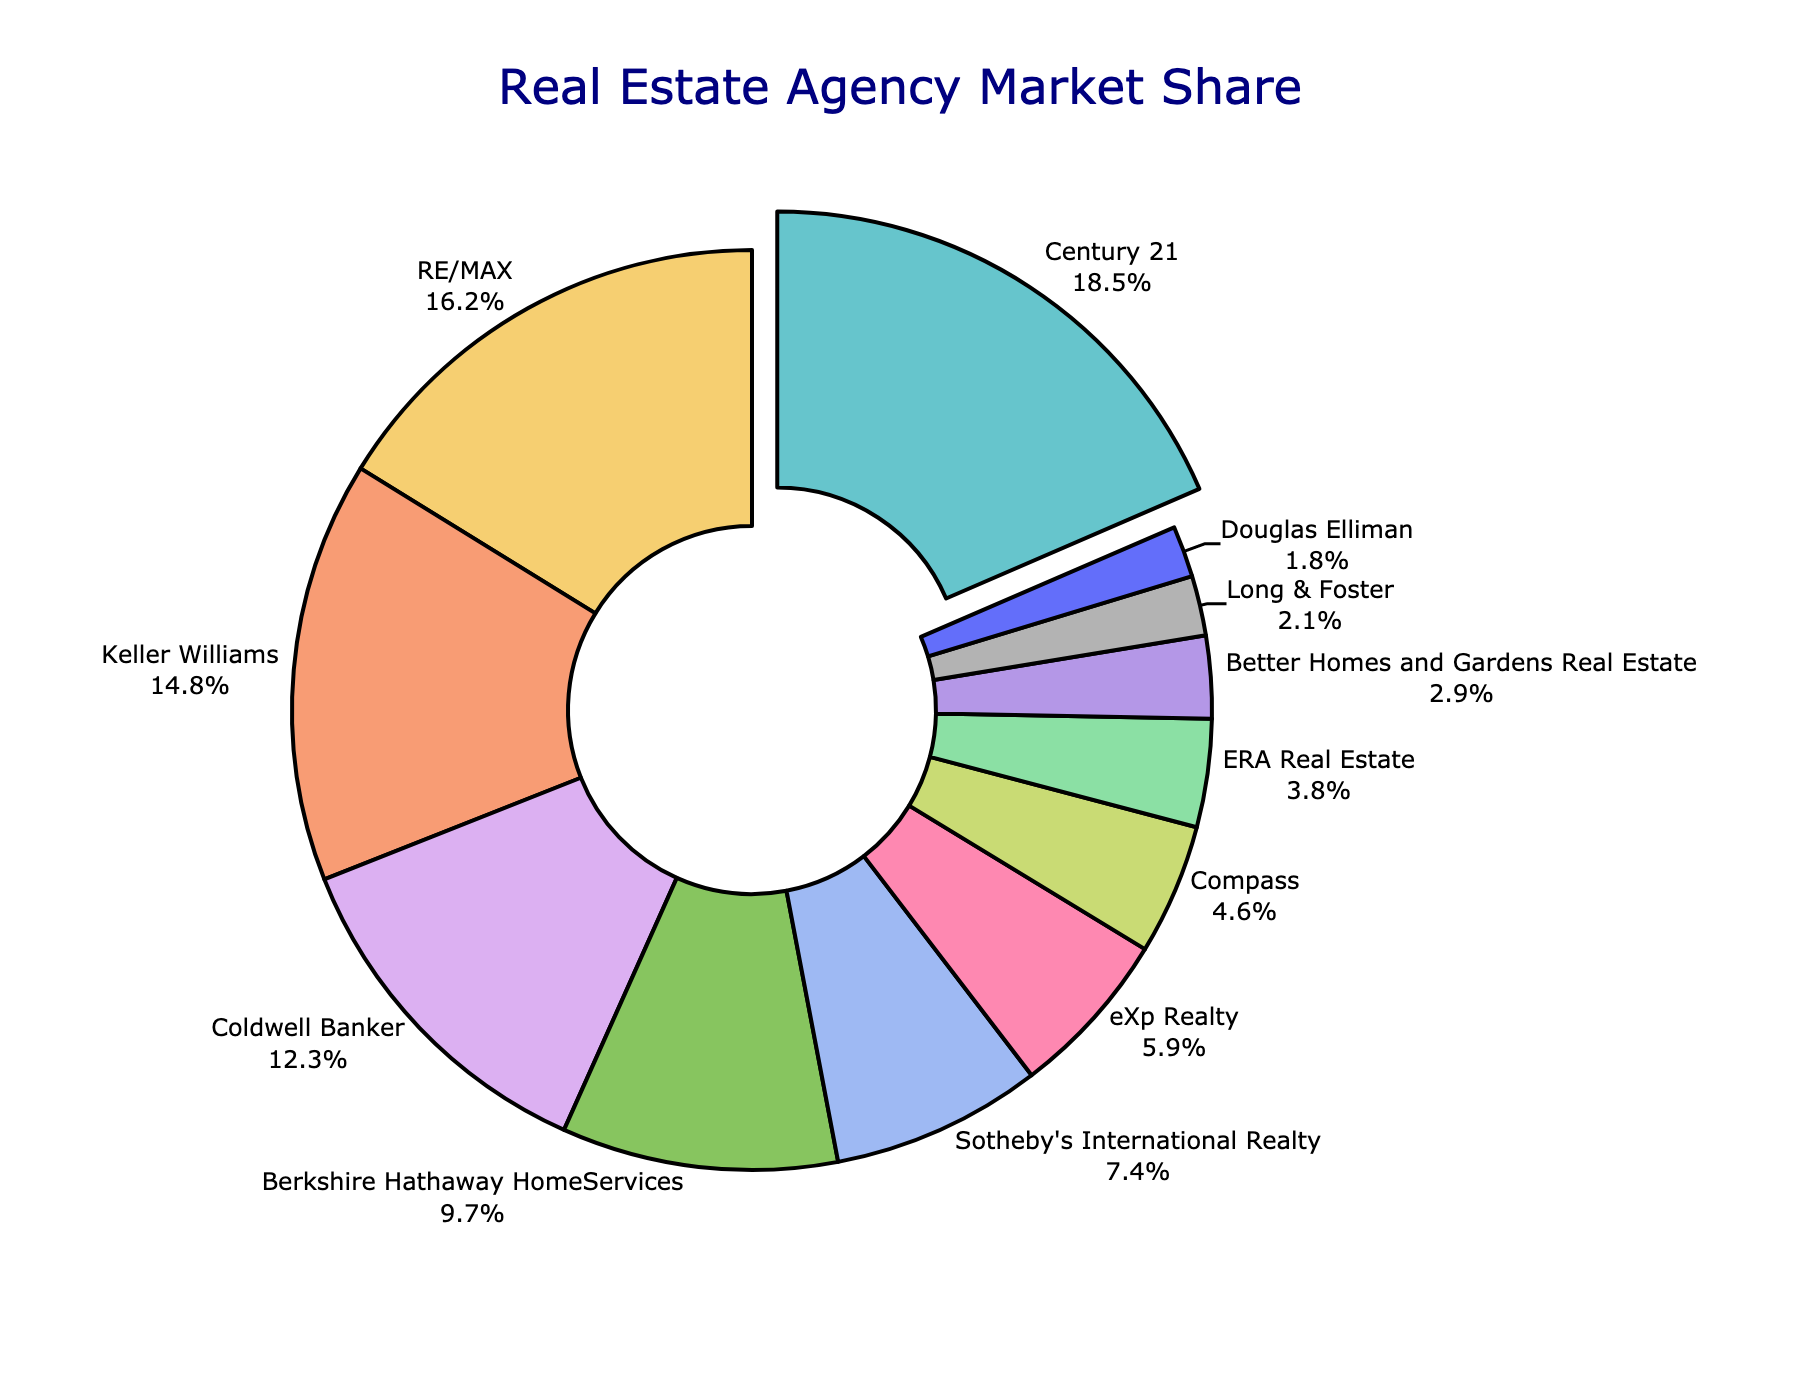What is the market share percentage of Century 21? Look at the pie chart and identify the section labeled "Century 21". The text will indicate its market share percentage.
Answer: 18.5% Which agency has the smallest market share? Observe the smallest section in the pie chart. The label which represents this section (Douglas Elliman) shows its market share.
Answer: Douglas Elliman What is the combined market share percentage of Century 21 and RE/MAX? Identify the sections labeled "Century 21" and "RE/MAX" on the pie chart. Sum their market share percentages: 18.5% + 16.2% = 34.7%.
Answer: 34.7% What is the difference in market share between Coldwell Banker and Berkshire Hathaway HomeServices? Locate the sections for Coldwell Banker and Berkshire Hathaway HomeServices on the pie chart. Subtract Berkshire Hathaway's share from Coldwell Banker's: 12.3% - 9.7% = 2.6%.
Answer: 2.6% Is eXp Realty's market share greater than Compass's? Compare the market share percentages of eXp Realty (5.9%) and Compass (4.6%) visible on their respective sections. eXp Realty's market share is greater.
Answer: Yes Which agency has a market share closest to 5%? Find the section whose label indicates a market share percentage nearest to 5%. This is eXp Realty with 5.9%.
Answer: eXp Realty How much more market share does Keller Williams have compared to ERA Real Estate? Identify the sections for Keller Williams (14.8%) and ERA Real Estate (3.8%) and subtract the smaller percentage from the larger one: 14.8% - 3.8% = 11%.
Answer: 11% What is the combined market share of the four agencies with the highest percentages? Add the market shares of Century 21 (18.5%), RE/MAX (16.2%), Keller Williams (14.8%), and Coldwell Banker (12.3%): 18.5% + 16.2% + 14.8% + 12.3% = 61.8%.
Answer: 61.8% How does the market share of Compass compare to Better Homes and Gardens Real Estate? Find and compare the sections for Compass (4.6%) and Better Homes and Gardens Real Estate (2.9%). Compass has a larger market share.
Answer: Compass has a larger market share Which agencies have a market share greater than 10%? Identify sections in the pie chart with market shares greater than 10%. These are Century 21 (18.5%), RE/MAX (16.2%), Keller Williams (14.8%), and Coldwell Banker (12.3%).
Answer: Century 21, RE/MAX, Keller Williams, Coldwell Banker 